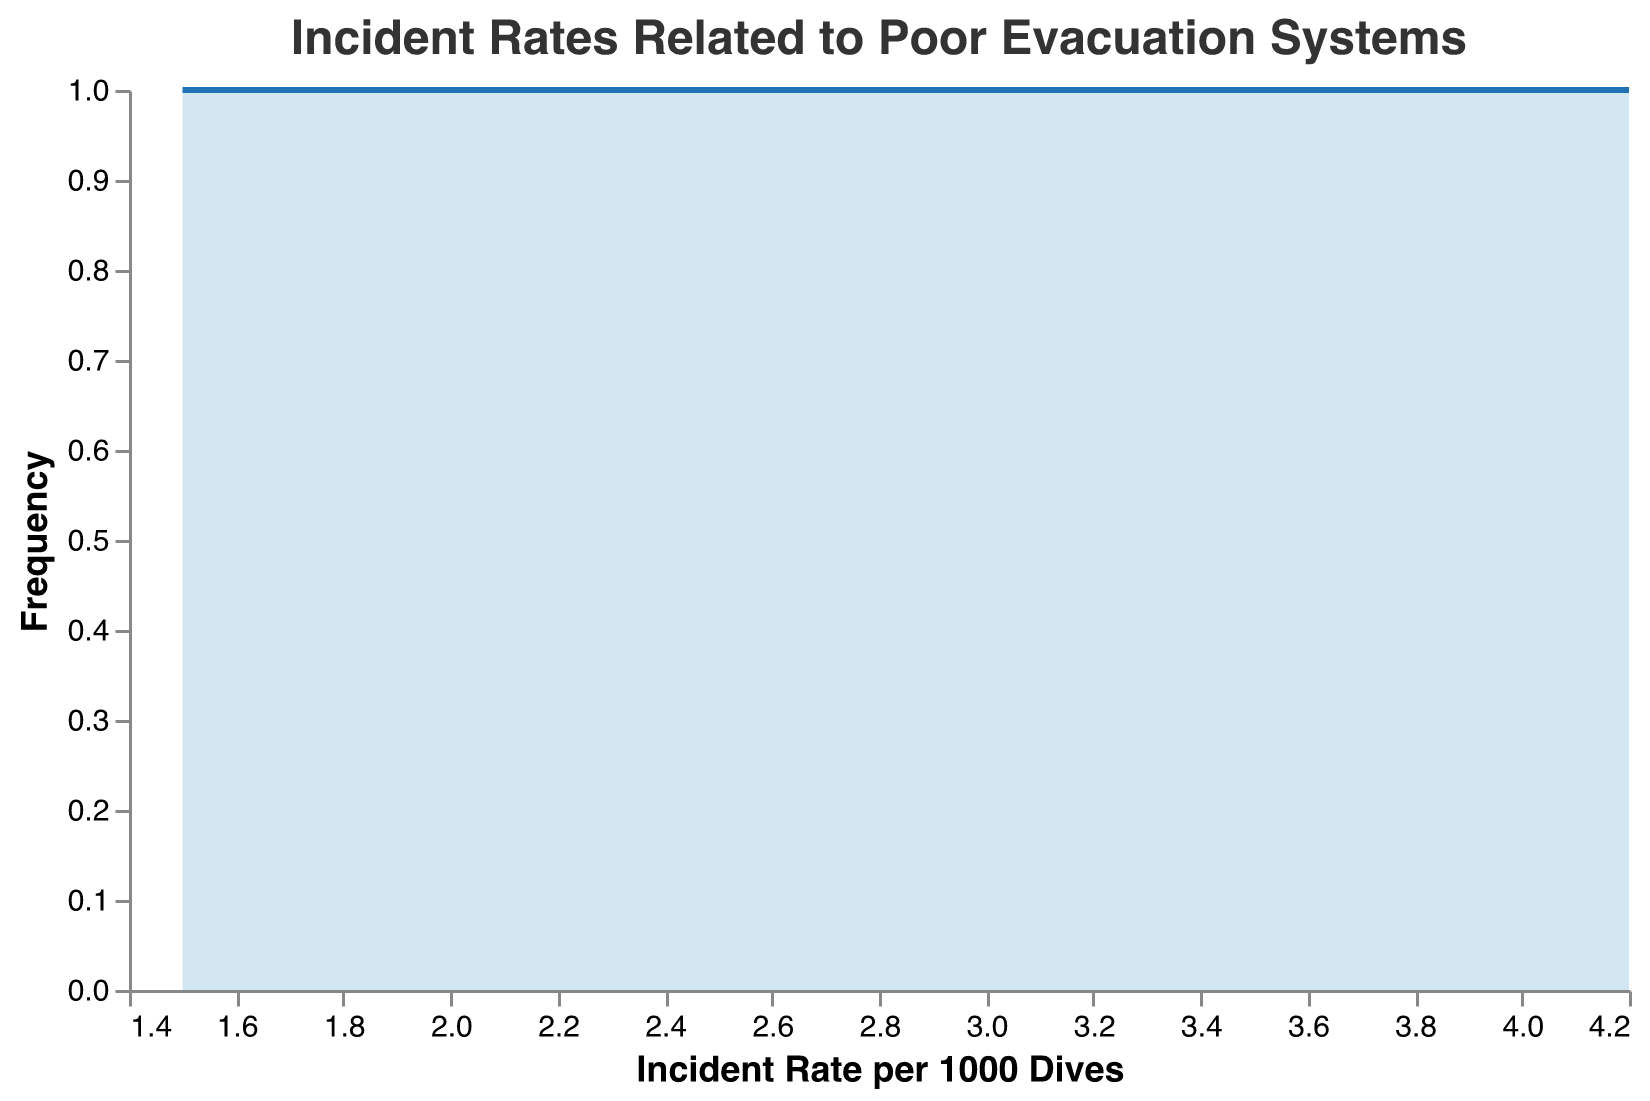What is the title of the figure? The title is typically located at the top of the figure. In this case, it reads "Incident Rates Related to Poor Evacuation Systems".
Answer: Incident Rates Related to Poor Evacuation Systems How many incident rates per 1000 dives are recorded in the data? By counting the data points, each corresponding to different incident rates, you can find the total number. Here, 12 data points are plotted.
Answer: 12 Which incident rate per 1000 dives had the highest frequency? Look for the peak of the area and line to determine the most frequent rate. The peak appears around 2.2 to 2.7 incident rates per 1000 dives.
Answer: 2.2 to 2.7 What is the range of the incident rates per 1000 dives shown in the figure? The range is found by identifying the minimum and maximum values on the x-axis. These values are 1.5 and 4.2 incident rates per 1000 dives, respectively.
Answer: 1.5 to 4.2 How many incidents had an incident rate greater than 3.0 per 1000 dives? Count the data points that have incident rates in this range: 3.1, 3.5, 3.7, 4.0, and 4.2. This gives 5 incidents.
Answer: 5 Which year had the highest recorded incident rate per 1000 dives, and what was the value? Review the details of each year and its corresponding incident rate. The highest rate is 4.2 in the year 2017.
Answer: 2017 and 4.2 What can be inferred about the general trend from the incident rates per 1000 dives over time? Observing the line, it is apparent that there is no clear increasing or decreasing trend; incident rates vary across different years.
Answer: No clear trend Is there any year where multiple incidents were recorded with the same incident rate? Compare incident rates for each year; the data shows unique values for each incident recorded per year.
Answer: No What was the most common evacuation system issue in the year with the highest incident rate? The highest incident rate was in 2017 at 4.2, and the issue was "Insufficient life rafts".
Answer: Insufficient life rafts 